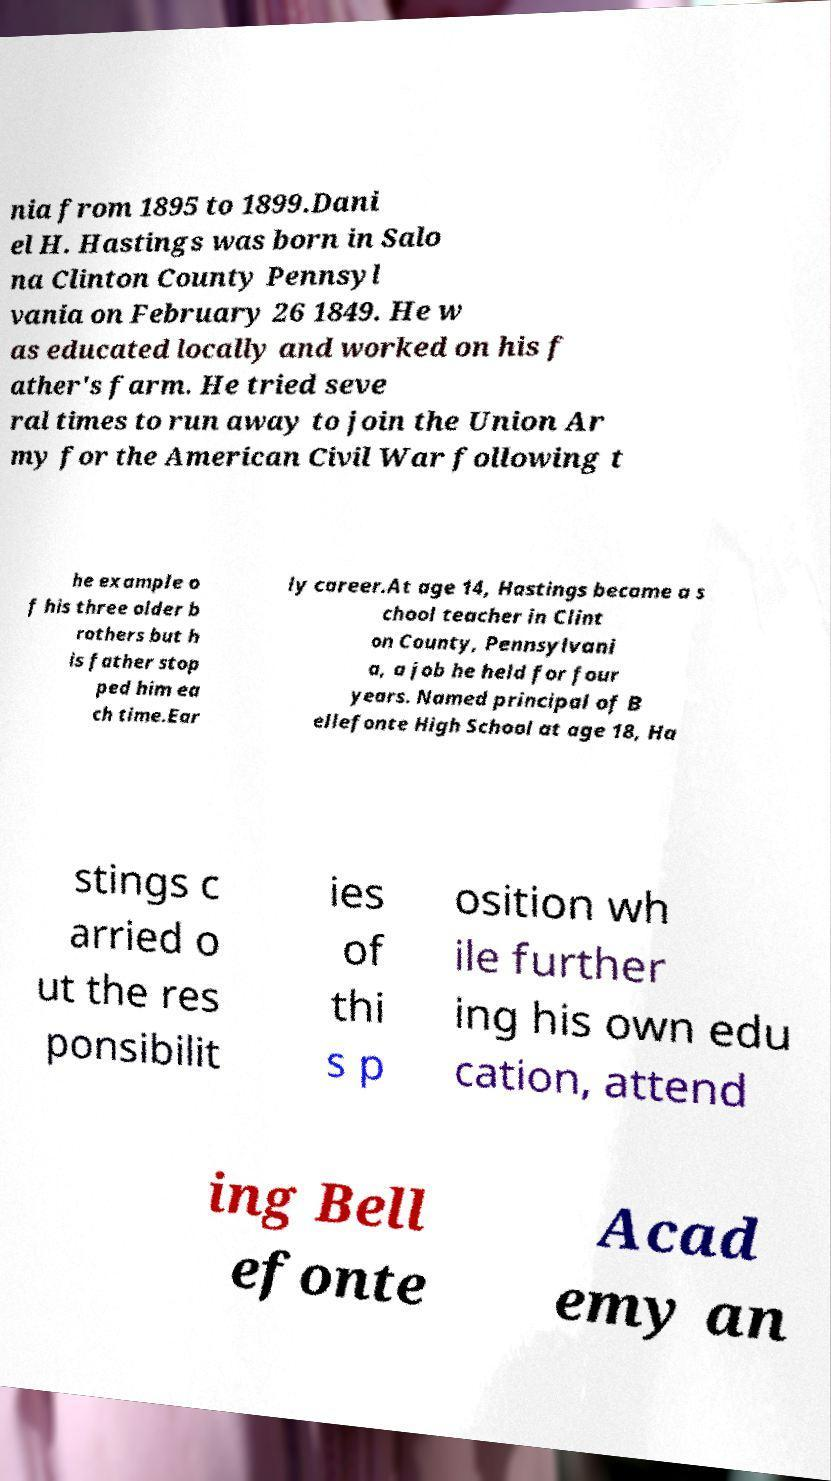What messages or text are displayed in this image? I need them in a readable, typed format. nia from 1895 to 1899.Dani el H. Hastings was born in Salo na Clinton County Pennsyl vania on February 26 1849. He w as educated locally and worked on his f ather's farm. He tried seve ral times to run away to join the Union Ar my for the American Civil War following t he example o f his three older b rothers but h is father stop ped him ea ch time.Ear ly career.At age 14, Hastings became a s chool teacher in Clint on County, Pennsylvani a, a job he held for four years. Named principal of B ellefonte High School at age 18, Ha stings c arried o ut the res ponsibilit ies of thi s p osition wh ile further ing his own edu cation, attend ing Bell efonte Acad emy an 